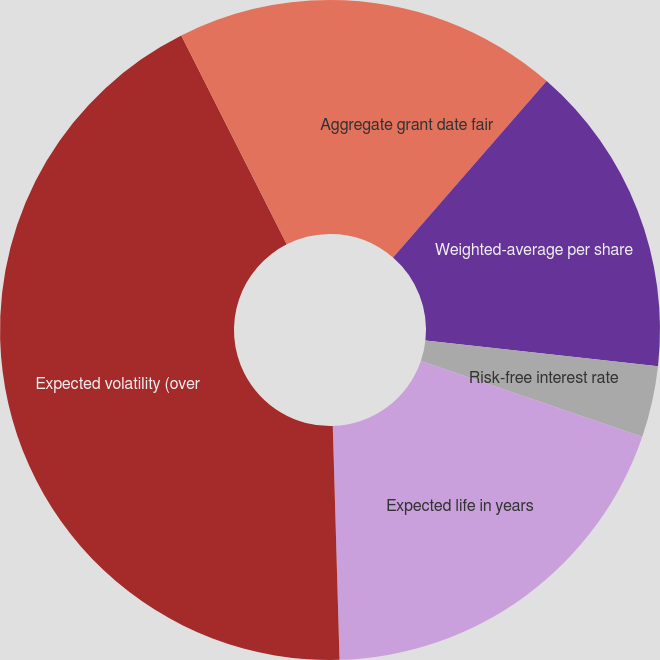<chart> <loc_0><loc_0><loc_500><loc_500><pie_chart><fcel>Aggregate grant date fair<fcel>Weighted-average per share<fcel>Risk-free interest rate<fcel>Expected life in years<fcel>Expected volatility (over<fcel>Expected dividend yield (over<nl><fcel>11.4%<fcel>15.35%<fcel>3.49%<fcel>19.3%<fcel>43.02%<fcel>7.44%<nl></chart> 